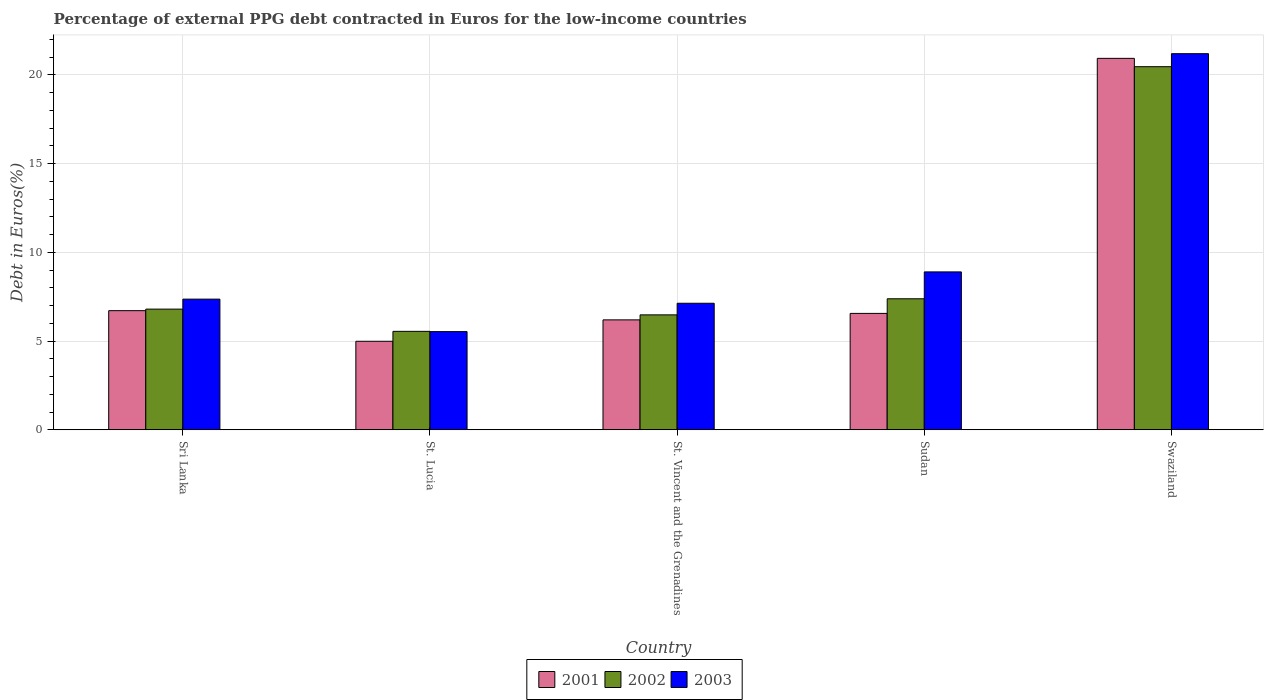How many groups of bars are there?
Ensure brevity in your answer.  5. How many bars are there on the 3rd tick from the left?
Your answer should be very brief. 3. What is the label of the 1st group of bars from the left?
Keep it short and to the point. Sri Lanka. In how many cases, is the number of bars for a given country not equal to the number of legend labels?
Keep it short and to the point. 0. What is the percentage of external PPG debt contracted in Euros in 2001 in Sri Lanka?
Your answer should be compact. 6.71. Across all countries, what is the maximum percentage of external PPG debt contracted in Euros in 2001?
Keep it short and to the point. 20.94. Across all countries, what is the minimum percentage of external PPG debt contracted in Euros in 2001?
Give a very brief answer. 4.99. In which country was the percentage of external PPG debt contracted in Euros in 2003 maximum?
Your answer should be very brief. Swaziland. In which country was the percentage of external PPG debt contracted in Euros in 2002 minimum?
Make the answer very short. St. Lucia. What is the total percentage of external PPG debt contracted in Euros in 2001 in the graph?
Ensure brevity in your answer.  45.4. What is the difference between the percentage of external PPG debt contracted in Euros in 2002 in St. Vincent and the Grenadines and that in Swaziland?
Give a very brief answer. -13.99. What is the difference between the percentage of external PPG debt contracted in Euros in 2002 in St. Vincent and the Grenadines and the percentage of external PPG debt contracted in Euros in 2001 in Swaziland?
Make the answer very short. -14.46. What is the average percentage of external PPG debt contracted in Euros in 2003 per country?
Make the answer very short. 10.03. What is the difference between the percentage of external PPG debt contracted in Euros of/in 2002 and percentage of external PPG debt contracted in Euros of/in 2001 in St. Vincent and the Grenadines?
Your answer should be very brief. 0.28. What is the ratio of the percentage of external PPG debt contracted in Euros in 2003 in St. Lucia to that in St. Vincent and the Grenadines?
Provide a succinct answer. 0.78. What is the difference between the highest and the second highest percentage of external PPG debt contracted in Euros in 2002?
Provide a short and direct response. 13.66. What is the difference between the highest and the lowest percentage of external PPG debt contracted in Euros in 2001?
Make the answer very short. 15.95. In how many countries, is the percentage of external PPG debt contracted in Euros in 2001 greater than the average percentage of external PPG debt contracted in Euros in 2001 taken over all countries?
Your answer should be compact. 1. What does the 1st bar from the right in St. Lucia represents?
Your response must be concise. 2003. What is the difference between two consecutive major ticks on the Y-axis?
Make the answer very short. 5. Are the values on the major ticks of Y-axis written in scientific E-notation?
Make the answer very short. No. How many legend labels are there?
Keep it short and to the point. 3. How are the legend labels stacked?
Offer a terse response. Horizontal. What is the title of the graph?
Your answer should be very brief. Percentage of external PPG debt contracted in Euros for the low-income countries. Does "2009" appear as one of the legend labels in the graph?
Keep it short and to the point. No. What is the label or title of the Y-axis?
Provide a short and direct response. Debt in Euros(%). What is the Debt in Euros(%) in 2001 in Sri Lanka?
Your answer should be very brief. 6.71. What is the Debt in Euros(%) of 2002 in Sri Lanka?
Make the answer very short. 6.8. What is the Debt in Euros(%) of 2003 in Sri Lanka?
Provide a short and direct response. 7.36. What is the Debt in Euros(%) in 2001 in St. Lucia?
Offer a very short reply. 4.99. What is the Debt in Euros(%) of 2002 in St. Lucia?
Your response must be concise. 5.55. What is the Debt in Euros(%) in 2003 in St. Lucia?
Offer a terse response. 5.53. What is the Debt in Euros(%) of 2001 in St. Vincent and the Grenadines?
Your answer should be very brief. 6.2. What is the Debt in Euros(%) in 2002 in St. Vincent and the Grenadines?
Provide a succinct answer. 6.48. What is the Debt in Euros(%) in 2003 in St. Vincent and the Grenadines?
Your answer should be compact. 7.13. What is the Debt in Euros(%) of 2001 in Sudan?
Provide a short and direct response. 6.56. What is the Debt in Euros(%) in 2002 in Sudan?
Your response must be concise. 7.39. What is the Debt in Euros(%) in 2003 in Sudan?
Give a very brief answer. 8.9. What is the Debt in Euros(%) of 2001 in Swaziland?
Your answer should be compact. 20.94. What is the Debt in Euros(%) of 2002 in Swaziland?
Your answer should be compact. 20.47. What is the Debt in Euros(%) in 2003 in Swaziland?
Offer a terse response. 21.2. Across all countries, what is the maximum Debt in Euros(%) in 2001?
Offer a terse response. 20.94. Across all countries, what is the maximum Debt in Euros(%) of 2002?
Keep it short and to the point. 20.47. Across all countries, what is the maximum Debt in Euros(%) in 2003?
Offer a terse response. 21.2. Across all countries, what is the minimum Debt in Euros(%) in 2001?
Offer a terse response. 4.99. Across all countries, what is the minimum Debt in Euros(%) of 2002?
Provide a short and direct response. 5.55. Across all countries, what is the minimum Debt in Euros(%) in 2003?
Make the answer very short. 5.53. What is the total Debt in Euros(%) of 2001 in the graph?
Your answer should be compact. 45.4. What is the total Debt in Euros(%) in 2002 in the graph?
Your response must be concise. 46.68. What is the total Debt in Euros(%) of 2003 in the graph?
Your answer should be very brief. 50.13. What is the difference between the Debt in Euros(%) of 2001 in Sri Lanka and that in St. Lucia?
Make the answer very short. 1.73. What is the difference between the Debt in Euros(%) of 2002 in Sri Lanka and that in St. Lucia?
Give a very brief answer. 1.25. What is the difference between the Debt in Euros(%) in 2003 in Sri Lanka and that in St. Lucia?
Your response must be concise. 1.83. What is the difference between the Debt in Euros(%) in 2001 in Sri Lanka and that in St. Vincent and the Grenadines?
Your response must be concise. 0.52. What is the difference between the Debt in Euros(%) of 2002 in Sri Lanka and that in St. Vincent and the Grenadines?
Provide a short and direct response. 0.32. What is the difference between the Debt in Euros(%) in 2003 in Sri Lanka and that in St. Vincent and the Grenadines?
Offer a very short reply. 0.23. What is the difference between the Debt in Euros(%) in 2001 in Sri Lanka and that in Sudan?
Keep it short and to the point. 0.15. What is the difference between the Debt in Euros(%) of 2002 in Sri Lanka and that in Sudan?
Offer a terse response. -0.58. What is the difference between the Debt in Euros(%) of 2003 in Sri Lanka and that in Sudan?
Offer a very short reply. -1.53. What is the difference between the Debt in Euros(%) in 2001 in Sri Lanka and that in Swaziland?
Provide a succinct answer. -14.22. What is the difference between the Debt in Euros(%) of 2002 in Sri Lanka and that in Swaziland?
Offer a terse response. -13.66. What is the difference between the Debt in Euros(%) of 2003 in Sri Lanka and that in Swaziland?
Offer a very short reply. -13.83. What is the difference between the Debt in Euros(%) of 2001 in St. Lucia and that in St. Vincent and the Grenadines?
Make the answer very short. -1.21. What is the difference between the Debt in Euros(%) in 2002 in St. Lucia and that in St. Vincent and the Grenadines?
Offer a very short reply. -0.93. What is the difference between the Debt in Euros(%) in 2003 in St. Lucia and that in St. Vincent and the Grenadines?
Offer a terse response. -1.6. What is the difference between the Debt in Euros(%) of 2001 in St. Lucia and that in Sudan?
Provide a succinct answer. -1.57. What is the difference between the Debt in Euros(%) in 2002 in St. Lucia and that in Sudan?
Ensure brevity in your answer.  -1.84. What is the difference between the Debt in Euros(%) in 2003 in St. Lucia and that in Sudan?
Offer a very short reply. -3.37. What is the difference between the Debt in Euros(%) in 2001 in St. Lucia and that in Swaziland?
Ensure brevity in your answer.  -15.95. What is the difference between the Debt in Euros(%) in 2002 in St. Lucia and that in Swaziland?
Offer a very short reply. -14.92. What is the difference between the Debt in Euros(%) of 2003 in St. Lucia and that in Swaziland?
Give a very brief answer. -15.66. What is the difference between the Debt in Euros(%) of 2001 in St. Vincent and the Grenadines and that in Sudan?
Offer a very short reply. -0.36. What is the difference between the Debt in Euros(%) in 2002 in St. Vincent and the Grenadines and that in Sudan?
Ensure brevity in your answer.  -0.91. What is the difference between the Debt in Euros(%) of 2003 in St. Vincent and the Grenadines and that in Sudan?
Keep it short and to the point. -1.77. What is the difference between the Debt in Euros(%) in 2001 in St. Vincent and the Grenadines and that in Swaziland?
Offer a very short reply. -14.74. What is the difference between the Debt in Euros(%) of 2002 in St. Vincent and the Grenadines and that in Swaziland?
Your response must be concise. -13.99. What is the difference between the Debt in Euros(%) in 2003 in St. Vincent and the Grenadines and that in Swaziland?
Provide a succinct answer. -14.07. What is the difference between the Debt in Euros(%) in 2001 in Sudan and that in Swaziland?
Your response must be concise. -14.37. What is the difference between the Debt in Euros(%) of 2002 in Sudan and that in Swaziland?
Your answer should be compact. -13.08. What is the difference between the Debt in Euros(%) in 2003 in Sudan and that in Swaziland?
Offer a very short reply. -12.3. What is the difference between the Debt in Euros(%) of 2001 in Sri Lanka and the Debt in Euros(%) of 2002 in St. Lucia?
Provide a succinct answer. 1.17. What is the difference between the Debt in Euros(%) of 2001 in Sri Lanka and the Debt in Euros(%) of 2003 in St. Lucia?
Provide a short and direct response. 1.18. What is the difference between the Debt in Euros(%) in 2002 in Sri Lanka and the Debt in Euros(%) in 2003 in St. Lucia?
Offer a terse response. 1.27. What is the difference between the Debt in Euros(%) of 2001 in Sri Lanka and the Debt in Euros(%) of 2002 in St. Vincent and the Grenadines?
Provide a succinct answer. 0.24. What is the difference between the Debt in Euros(%) of 2001 in Sri Lanka and the Debt in Euros(%) of 2003 in St. Vincent and the Grenadines?
Offer a terse response. -0.42. What is the difference between the Debt in Euros(%) in 2002 in Sri Lanka and the Debt in Euros(%) in 2003 in St. Vincent and the Grenadines?
Keep it short and to the point. -0.33. What is the difference between the Debt in Euros(%) of 2001 in Sri Lanka and the Debt in Euros(%) of 2002 in Sudan?
Provide a succinct answer. -0.67. What is the difference between the Debt in Euros(%) of 2001 in Sri Lanka and the Debt in Euros(%) of 2003 in Sudan?
Your answer should be very brief. -2.18. What is the difference between the Debt in Euros(%) in 2002 in Sri Lanka and the Debt in Euros(%) in 2003 in Sudan?
Your answer should be very brief. -2.1. What is the difference between the Debt in Euros(%) in 2001 in Sri Lanka and the Debt in Euros(%) in 2002 in Swaziland?
Provide a short and direct response. -13.75. What is the difference between the Debt in Euros(%) of 2001 in Sri Lanka and the Debt in Euros(%) of 2003 in Swaziland?
Provide a succinct answer. -14.48. What is the difference between the Debt in Euros(%) of 2002 in Sri Lanka and the Debt in Euros(%) of 2003 in Swaziland?
Your answer should be very brief. -14.4. What is the difference between the Debt in Euros(%) in 2001 in St. Lucia and the Debt in Euros(%) in 2002 in St. Vincent and the Grenadines?
Your response must be concise. -1.49. What is the difference between the Debt in Euros(%) of 2001 in St. Lucia and the Debt in Euros(%) of 2003 in St. Vincent and the Grenadines?
Offer a very short reply. -2.14. What is the difference between the Debt in Euros(%) of 2002 in St. Lucia and the Debt in Euros(%) of 2003 in St. Vincent and the Grenadines?
Provide a succinct answer. -1.58. What is the difference between the Debt in Euros(%) of 2001 in St. Lucia and the Debt in Euros(%) of 2002 in Sudan?
Your answer should be compact. -2.4. What is the difference between the Debt in Euros(%) of 2001 in St. Lucia and the Debt in Euros(%) of 2003 in Sudan?
Provide a short and direct response. -3.91. What is the difference between the Debt in Euros(%) of 2002 in St. Lucia and the Debt in Euros(%) of 2003 in Sudan?
Give a very brief answer. -3.35. What is the difference between the Debt in Euros(%) in 2001 in St. Lucia and the Debt in Euros(%) in 2002 in Swaziland?
Your answer should be compact. -15.48. What is the difference between the Debt in Euros(%) of 2001 in St. Lucia and the Debt in Euros(%) of 2003 in Swaziland?
Your answer should be compact. -16.21. What is the difference between the Debt in Euros(%) of 2002 in St. Lucia and the Debt in Euros(%) of 2003 in Swaziland?
Make the answer very short. -15.65. What is the difference between the Debt in Euros(%) in 2001 in St. Vincent and the Grenadines and the Debt in Euros(%) in 2002 in Sudan?
Make the answer very short. -1.19. What is the difference between the Debt in Euros(%) in 2001 in St. Vincent and the Grenadines and the Debt in Euros(%) in 2003 in Sudan?
Your answer should be compact. -2.7. What is the difference between the Debt in Euros(%) in 2002 in St. Vincent and the Grenadines and the Debt in Euros(%) in 2003 in Sudan?
Keep it short and to the point. -2.42. What is the difference between the Debt in Euros(%) of 2001 in St. Vincent and the Grenadines and the Debt in Euros(%) of 2002 in Swaziland?
Give a very brief answer. -14.27. What is the difference between the Debt in Euros(%) in 2001 in St. Vincent and the Grenadines and the Debt in Euros(%) in 2003 in Swaziland?
Keep it short and to the point. -15. What is the difference between the Debt in Euros(%) of 2002 in St. Vincent and the Grenadines and the Debt in Euros(%) of 2003 in Swaziland?
Offer a very short reply. -14.72. What is the difference between the Debt in Euros(%) of 2001 in Sudan and the Debt in Euros(%) of 2002 in Swaziland?
Give a very brief answer. -13.9. What is the difference between the Debt in Euros(%) of 2001 in Sudan and the Debt in Euros(%) of 2003 in Swaziland?
Provide a succinct answer. -14.64. What is the difference between the Debt in Euros(%) of 2002 in Sudan and the Debt in Euros(%) of 2003 in Swaziland?
Your response must be concise. -13.81. What is the average Debt in Euros(%) in 2001 per country?
Your answer should be compact. 9.08. What is the average Debt in Euros(%) of 2002 per country?
Offer a very short reply. 9.34. What is the average Debt in Euros(%) of 2003 per country?
Your response must be concise. 10.03. What is the difference between the Debt in Euros(%) of 2001 and Debt in Euros(%) of 2002 in Sri Lanka?
Keep it short and to the point. -0.09. What is the difference between the Debt in Euros(%) of 2001 and Debt in Euros(%) of 2003 in Sri Lanka?
Provide a succinct answer. -0.65. What is the difference between the Debt in Euros(%) in 2002 and Debt in Euros(%) in 2003 in Sri Lanka?
Keep it short and to the point. -0.56. What is the difference between the Debt in Euros(%) of 2001 and Debt in Euros(%) of 2002 in St. Lucia?
Provide a short and direct response. -0.56. What is the difference between the Debt in Euros(%) in 2001 and Debt in Euros(%) in 2003 in St. Lucia?
Make the answer very short. -0.54. What is the difference between the Debt in Euros(%) in 2002 and Debt in Euros(%) in 2003 in St. Lucia?
Your answer should be compact. 0.01. What is the difference between the Debt in Euros(%) in 2001 and Debt in Euros(%) in 2002 in St. Vincent and the Grenadines?
Provide a short and direct response. -0.28. What is the difference between the Debt in Euros(%) in 2001 and Debt in Euros(%) in 2003 in St. Vincent and the Grenadines?
Provide a short and direct response. -0.94. What is the difference between the Debt in Euros(%) in 2002 and Debt in Euros(%) in 2003 in St. Vincent and the Grenadines?
Give a very brief answer. -0.65. What is the difference between the Debt in Euros(%) in 2001 and Debt in Euros(%) in 2002 in Sudan?
Your response must be concise. -0.82. What is the difference between the Debt in Euros(%) of 2001 and Debt in Euros(%) of 2003 in Sudan?
Make the answer very short. -2.34. What is the difference between the Debt in Euros(%) in 2002 and Debt in Euros(%) in 2003 in Sudan?
Offer a terse response. -1.51. What is the difference between the Debt in Euros(%) of 2001 and Debt in Euros(%) of 2002 in Swaziland?
Your answer should be very brief. 0.47. What is the difference between the Debt in Euros(%) of 2001 and Debt in Euros(%) of 2003 in Swaziland?
Keep it short and to the point. -0.26. What is the difference between the Debt in Euros(%) of 2002 and Debt in Euros(%) of 2003 in Swaziland?
Offer a very short reply. -0.73. What is the ratio of the Debt in Euros(%) of 2001 in Sri Lanka to that in St. Lucia?
Your answer should be very brief. 1.35. What is the ratio of the Debt in Euros(%) of 2002 in Sri Lanka to that in St. Lucia?
Ensure brevity in your answer.  1.23. What is the ratio of the Debt in Euros(%) of 2003 in Sri Lanka to that in St. Lucia?
Keep it short and to the point. 1.33. What is the ratio of the Debt in Euros(%) in 2001 in Sri Lanka to that in St. Vincent and the Grenadines?
Provide a succinct answer. 1.08. What is the ratio of the Debt in Euros(%) of 2003 in Sri Lanka to that in St. Vincent and the Grenadines?
Give a very brief answer. 1.03. What is the ratio of the Debt in Euros(%) in 2001 in Sri Lanka to that in Sudan?
Provide a short and direct response. 1.02. What is the ratio of the Debt in Euros(%) of 2002 in Sri Lanka to that in Sudan?
Give a very brief answer. 0.92. What is the ratio of the Debt in Euros(%) of 2003 in Sri Lanka to that in Sudan?
Your answer should be very brief. 0.83. What is the ratio of the Debt in Euros(%) of 2001 in Sri Lanka to that in Swaziland?
Your answer should be very brief. 0.32. What is the ratio of the Debt in Euros(%) in 2002 in Sri Lanka to that in Swaziland?
Ensure brevity in your answer.  0.33. What is the ratio of the Debt in Euros(%) in 2003 in Sri Lanka to that in Swaziland?
Keep it short and to the point. 0.35. What is the ratio of the Debt in Euros(%) in 2001 in St. Lucia to that in St. Vincent and the Grenadines?
Ensure brevity in your answer.  0.81. What is the ratio of the Debt in Euros(%) of 2002 in St. Lucia to that in St. Vincent and the Grenadines?
Keep it short and to the point. 0.86. What is the ratio of the Debt in Euros(%) of 2003 in St. Lucia to that in St. Vincent and the Grenadines?
Keep it short and to the point. 0.78. What is the ratio of the Debt in Euros(%) of 2001 in St. Lucia to that in Sudan?
Keep it short and to the point. 0.76. What is the ratio of the Debt in Euros(%) of 2002 in St. Lucia to that in Sudan?
Keep it short and to the point. 0.75. What is the ratio of the Debt in Euros(%) of 2003 in St. Lucia to that in Sudan?
Ensure brevity in your answer.  0.62. What is the ratio of the Debt in Euros(%) of 2001 in St. Lucia to that in Swaziland?
Your answer should be compact. 0.24. What is the ratio of the Debt in Euros(%) of 2002 in St. Lucia to that in Swaziland?
Your response must be concise. 0.27. What is the ratio of the Debt in Euros(%) in 2003 in St. Lucia to that in Swaziland?
Provide a short and direct response. 0.26. What is the ratio of the Debt in Euros(%) in 2002 in St. Vincent and the Grenadines to that in Sudan?
Offer a very short reply. 0.88. What is the ratio of the Debt in Euros(%) of 2003 in St. Vincent and the Grenadines to that in Sudan?
Offer a very short reply. 0.8. What is the ratio of the Debt in Euros(%) in 2001 in St. Vincent and the Grenadines to that in Swaziland?
Your answer should be compact. 0.3. What is the ratio of the Debt in Euros(%) in 2002 in St. Vincent and the Grenadines to that in Swaziland?
Provide a succinct answer. 0.32. What is the ratio of the Debt in Euros(%) in 2003 in St. Vincent and the Grenadines to that in Swaziland?
Make the answer very short. 0.34. What is the ratio of the Debt in Euros(%) of 2001 in Sudan to that in Swaziland?
Your response must be concise. 0.31. What is the ratio of the Debt in Euros(%) of 2002 in Sudan to that in Swaziland?
Provide a succinct answer. 0.36. What is the ratio of the Debt in Euros(%) in 2003 in Sudan to that in Swaziland?
Offer a terse response. 0.42. What is the difference between the highest and the second highest Debt in Euros(%) in 2001?
Offer a terse response. 14.22. What is the difference between the highest and the second highest Debt in Euros(%) in 2002?
Provide a short and direct response. 13.08. What is the difference between the highest and the second highest Debt in Euros(%) in 2003?
Give a very brief answer. 12.3. What is the difference between the highest and the lowest Debt in Euros(%) in 2001?
Your answer should be compact. 15.95. What is the difference between the highest and the lowest Debt in Euros(%) of 2002?
Offer a terse response. 14.92. What is the difference between the highest and the lowest Debt in Euros(%) of 2003?
Your response must be concise. 15.66. 